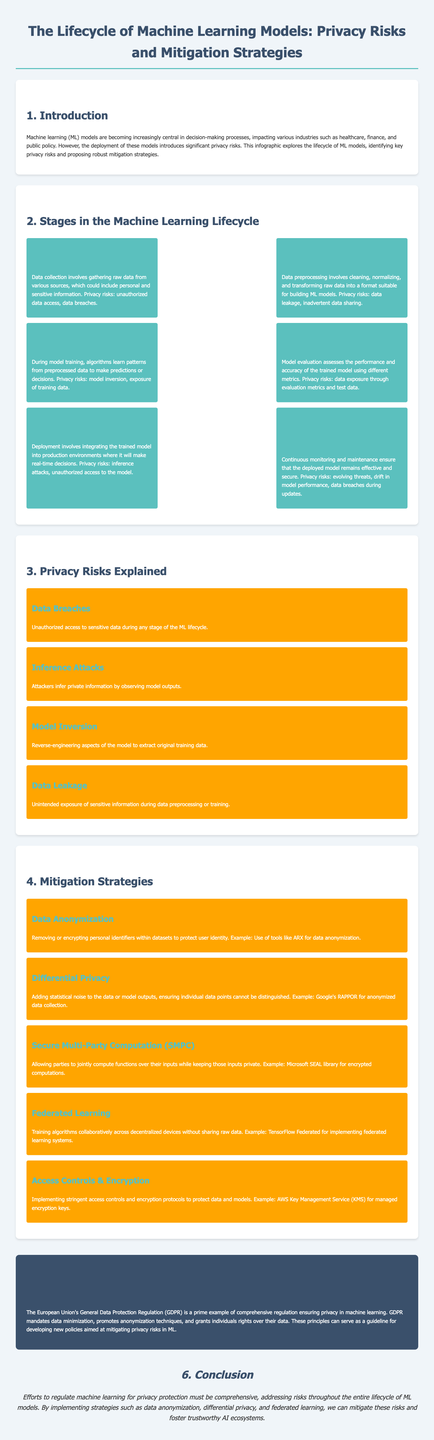What is the title of the infographic? The title is clearly stated at the top of the document, which outlines the focus of the content.
Answer: The Lifecycle of Machine Learning Models: Privacy Risks and Mitigation Strategies What stage follows Data Preprocessing? The lifecycle stages are listed in a sequence, and after Data Preprocessing, the next stage is identified.
Answer: Model Training What is one privacy risk associated with Model Evaluation? The document outlines risks for each lifecycle stage, including the specific risk related to Model Evaluation.
Answer: Data exposure through evaluation metrics and test data Name one mitigation strategy mentioned for privacy protection. The document lists several mitigation strategies aimed at enhancing privacy in machine learning, one of which can be cited.
Answer: Data Anonymization Which regulation is cited as a case study for ensuring privacy in machine learning? The document provides an example of regulation that addresses privacy issues related to machine learning models.
Answer: General Data Protection Regulation (GDPR) How many stages are in the Machine Learning Lifecycle? By counting the stages listed, the total number of stages can be derived from the document.
Answer: Six What example is given for Federated Learning? The document includes specific examples of tools used in each mitigation strategy, which can be referenced here.
Answer: TensorFlow Federated What is a risk of Data Collection? The document describes specific risks associated with each lifecycle stage, including this one.
Answer: Unauthorized data access Which privacy strategy uses statistical noise? Among the strategies discussed, this one is specifically related to modifying data or outputs to protect privacy.
Answer: Differential Privacy 